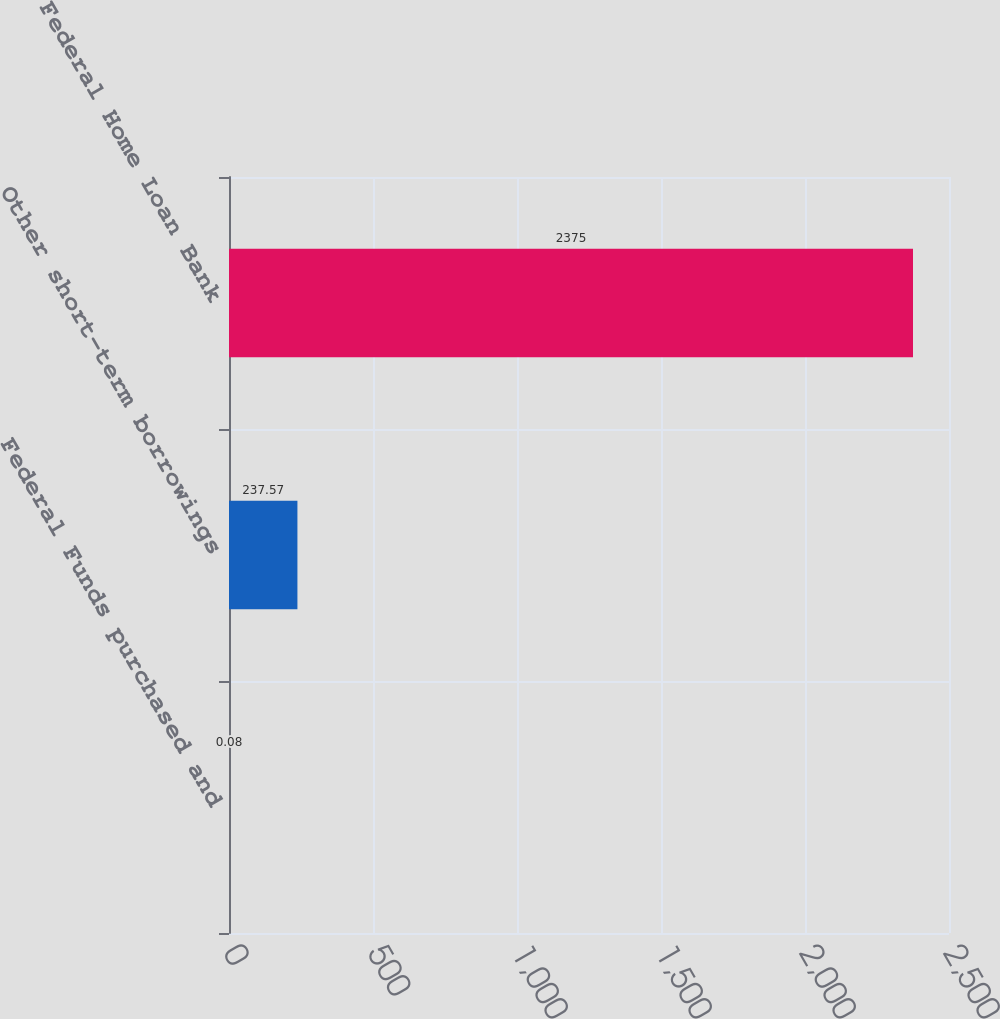<chart> <loc_0><loc_0><loc_500><loc_500><bar_chart><fcel>Federal Funds purchased and<fcel>Other short-term borrowings<fcel>Federal Home Loan Bank<nl><fcel>0.08<fcel>237.57<fcel>2375<nl></chart> 